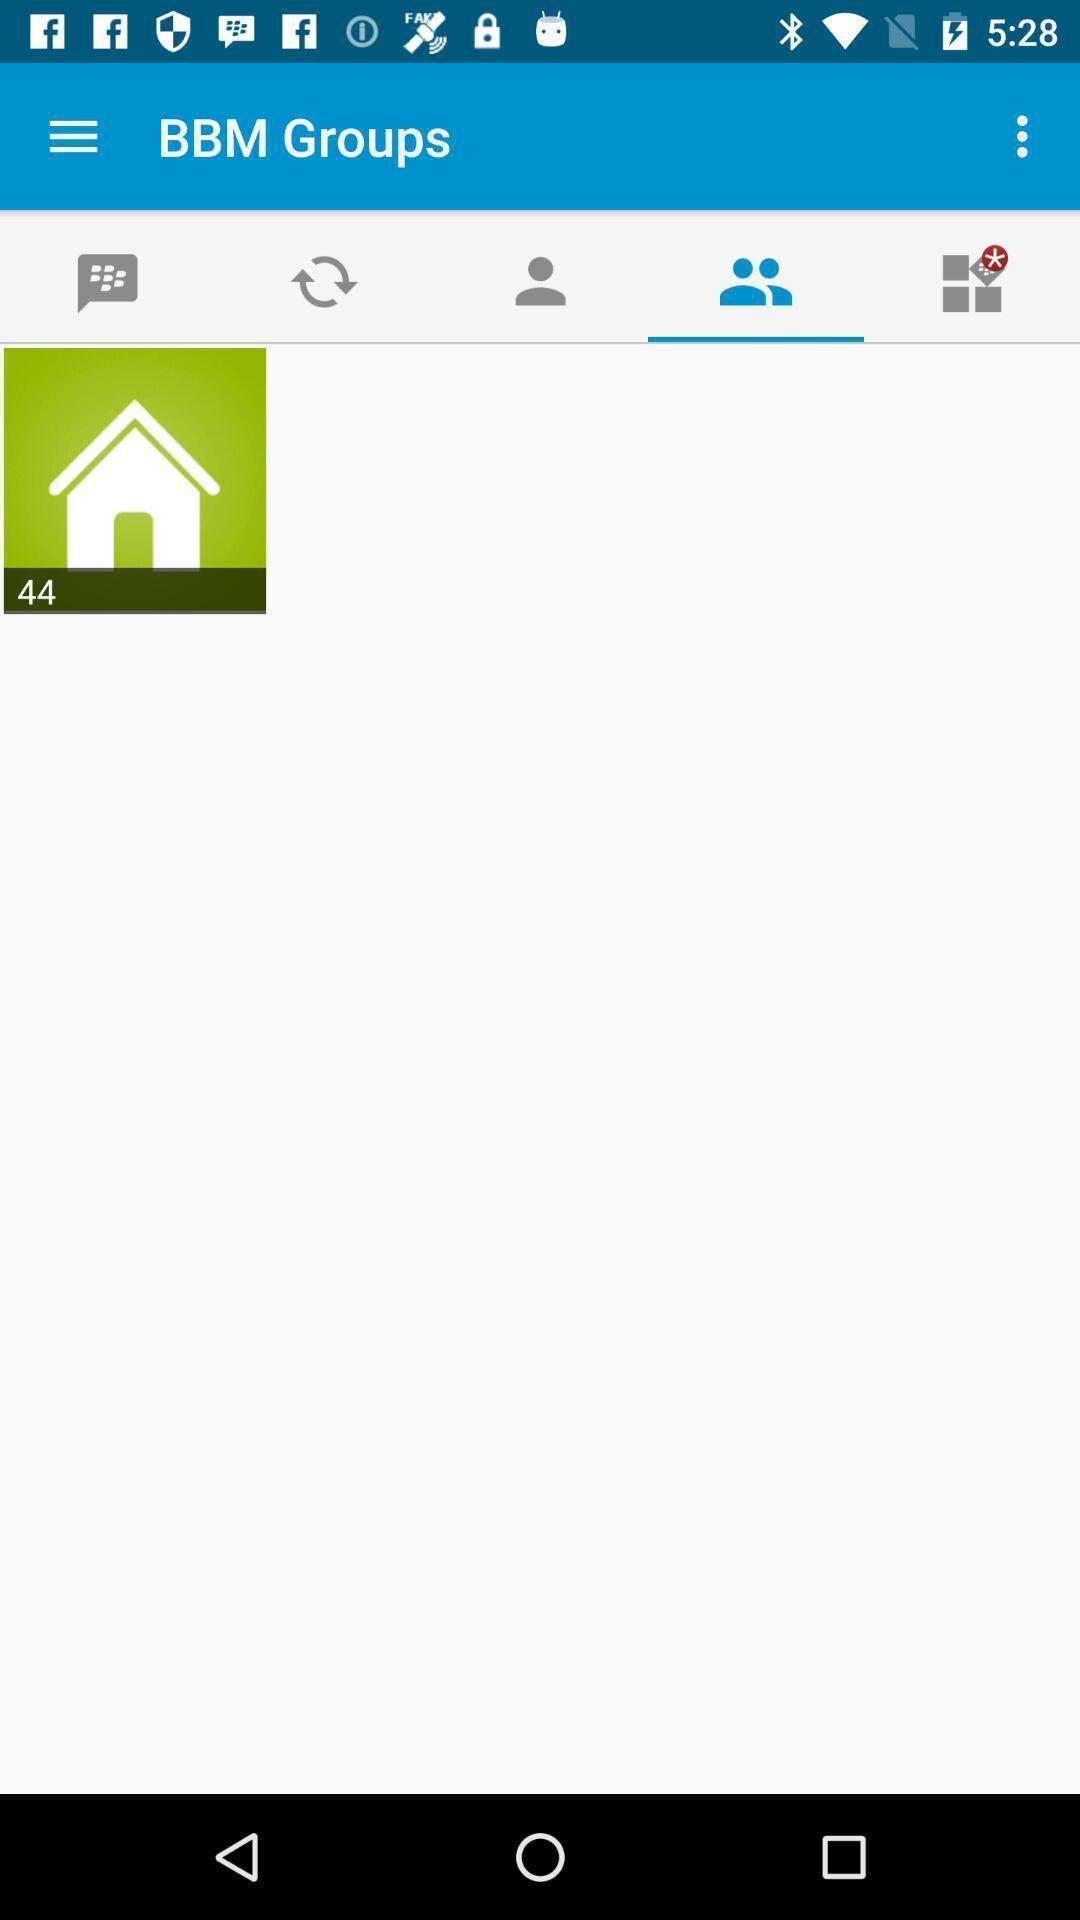Tell me about the visual elements in this screen capture. Page displaying different options. 